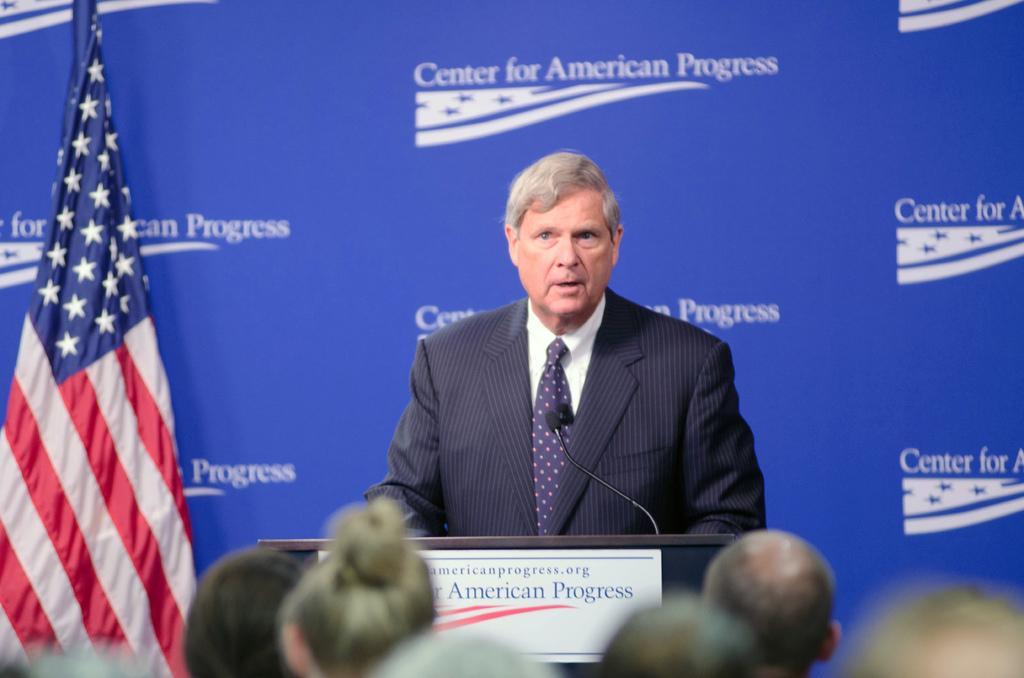How would you summarize this image in a sentence or two? In this image there are people, in the background there is a person standing in front of a podium, on that podium there is a mic and there is some text and there is a banner, on that banner there is some text and there is a flag. 